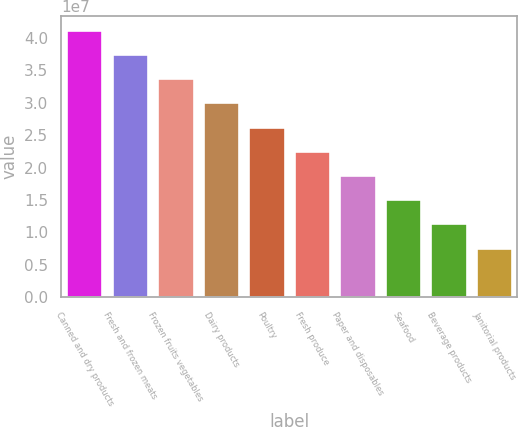Convert chart to OTSL. <chart><loc_0><loc_0><loc_500><loc_500><bar_chart><fcel>Canned and dry products<fcel>Fresh and frozen meats<fcel>Frozen fruits vegetables<fcel>Dairy products<fcel>Poultry<fcel>Fresh produce<fcel>Paper and disposables<fcel>Seafood<fcel>Beverage products<fcel>Janitorial products<nl><fcel>4.1258e+07<fcel>3.75221e+07<fcel>3.37863e+07<fcel>3.00504e+07<fcel>2.63146e+07<fcel>2.25787e+07<fcel>1.88429e+07<fcel>1.5107e+07<fcel>1.13712e+07<fcel>7.63536e+06<nl></chart> 